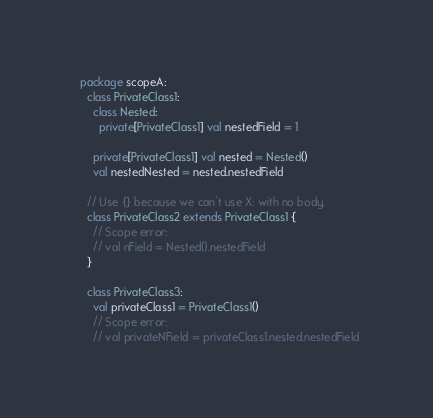Convert code to text. <code><loc_0><loc_0><loc_500><loc_500><_Scala_>  package scopeA:
    class PrivateClass1:
      class Nested:
        private[PrivateClass1] val nestedField = 1

      private[PrivateClass1] val nested = Nested()
      val nestedNested = nested.nestedField

    // Use {} because we can't use X: with no body.
    class PrivateClass2 extends PrivateClass1 {
      // Scope error:
      // val nField = Nested().nestedField
    }

    class PrivateClass3:
      val privateClass1 = PrivateClass1()
      // Scope error:
      // val privateNField = privateClass1.nested.nestedField
</code> 